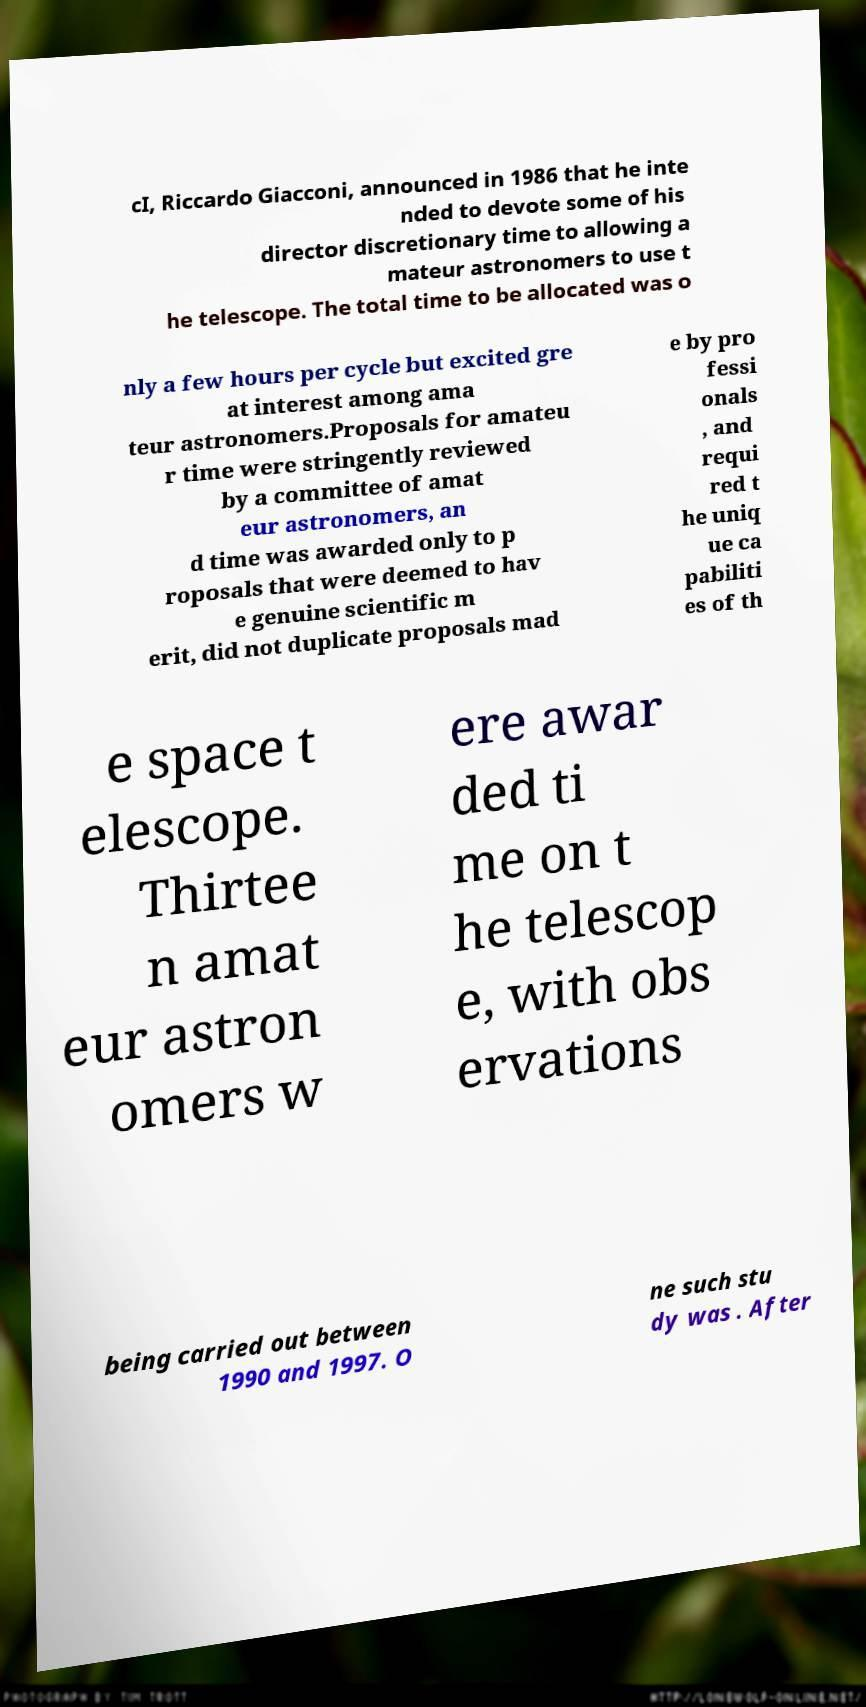Please identify and transcribe the text found in this image. cI, Riccardo Giacconi, announced in 1986 that he inte nded to devote some of his director discretionary time to allowing a mateur astronomers to use t he telescope. The total time to be allocated was o nly a few hours per cycle but excited gre at interest among ama teur astronomers.Proposals for amateu r time were stringently reviewed by a committee of amat eur astronomers, an d time was awarded only to p roposals that were deemed to hav e genuine scientific m erit, did not duplicate proposals mad e by pro fessi onals , and requi red t he uniq ue ca pabiliti es of th e space t elescope. Thirtee n amat eur astron omers w ere awar ded ti me on t he telescop e, with obs ervations being carried out between 1990 and 1997. O ne such stu dy was . After 